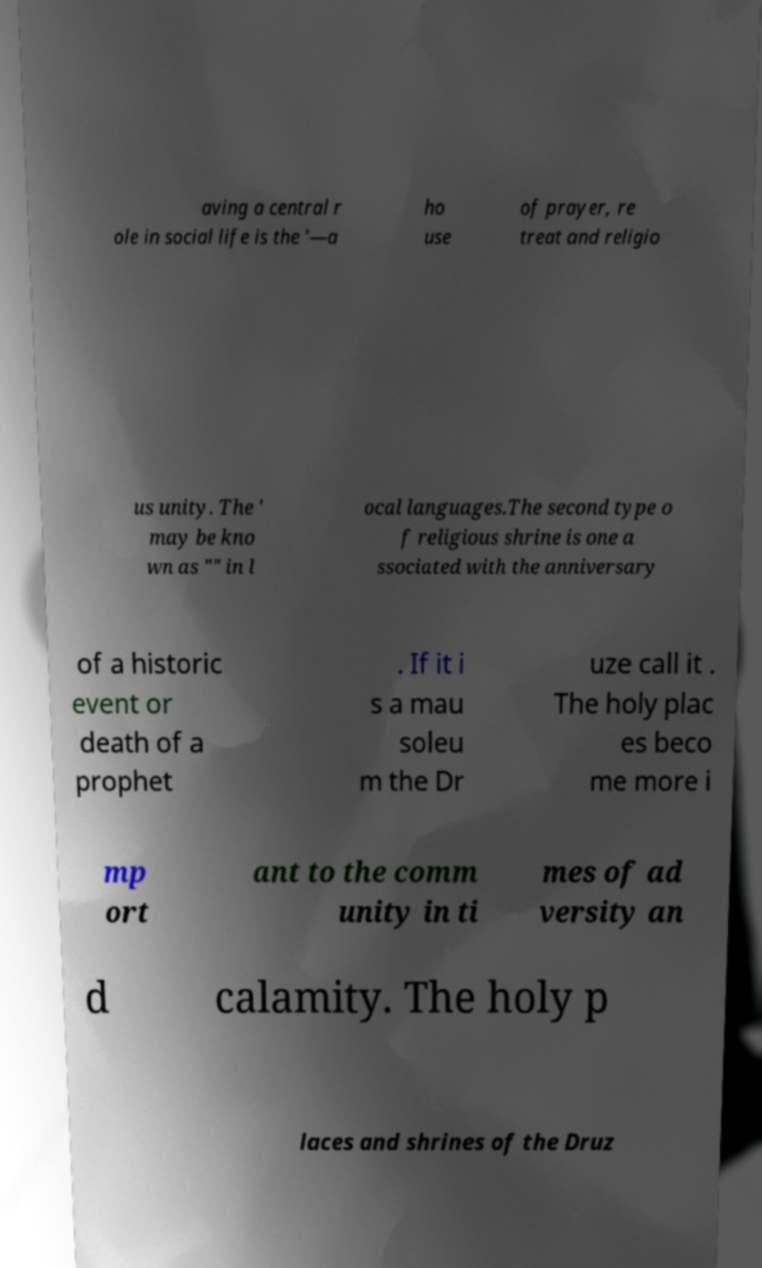For documentation purposes, I need the text within this image transcribed. Could you provide that? aving a central r ole in social life is the '—a ho use of prayer, re treat and religio us unity. The ' may be kno wn as "" in l ocal languages.The second type o f religious shrine is one a ssociated with the anniversary of a historic event or death of a prophet . If it i s a mau soleu m the Dr uze call it . The holy plac es beco me more i mp ort ant to the comm unity in ti mes of ad versity an d calamity. The holy p laces and shrines of the Druz 